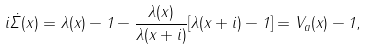<formula> <loc_0><loc_0><loc_500><loc_500>i \dot { \Sigma } ( x ) = \lambda ( x ) - 1 - \frac { \lambda ( x ) } { \lambda ( x + i ) } [ \lambda ( x + i ) - 1 ] = V _ { a } ( x ) - 1 ,</formula> 